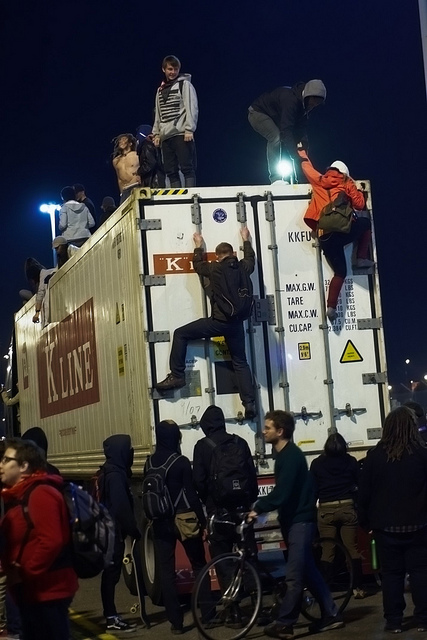Identify the text contained in this image. MAXCW TARE MAXCW KKFU K CAP K LINE 